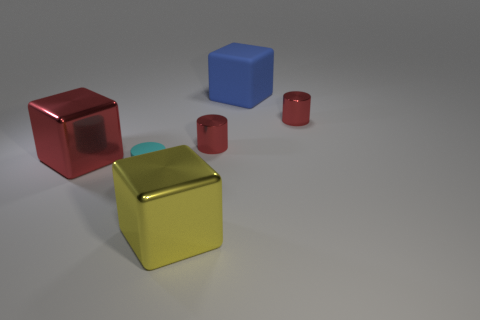There is a blue thing; does it have the same shape as the red object left of the small matte object?
Provide a succinct answer. Yes. There is a tiny object that is to the left of the large shiny object that is to the right of the thing to the left of the cyan cylinder; what is its color?
Your answer should be compact. Cyan. There is a yellow metallic block; are there any red metallic things to the right of it?
Your answer should be compact. Yes. Are there any other big blocks made of the same material as the large yellow block?
Make the answer very short. Yes. The large rubber block is what color?
Make the answer very short. Blue. Do the large thing that is to the right of the large yellow object and the large red thing have the same shape?
Keep it short and to the point. Yes. What is the shape of the matte object that is behind the matte thing that is in front of the big shiny thing that is left of the yellow shiny cube?
Keep it short and to the point. Cube. What material is the yellow cube in front of the blue matte object?
Your answer should be compact. Metal. What is the color of the other metal object that is the same size as the yellow shiny thing?
Offer a terse response. Red. Is the size of the blue object the same as the yellow metal thing?
Your answer should be very brief. Yes. 